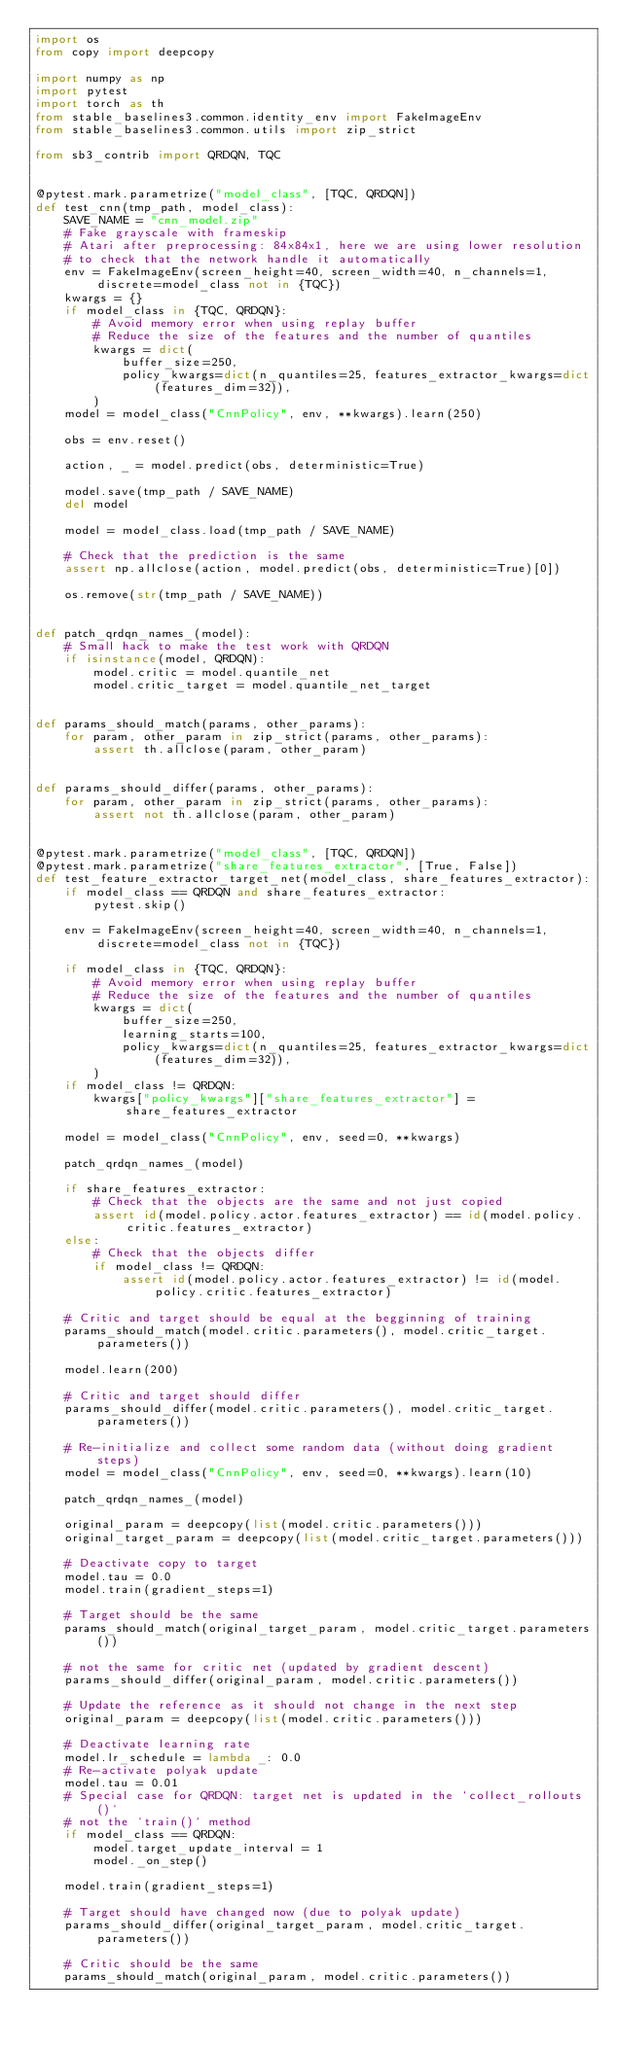<code> <loc_0><loc_0><loc_500><loc_500><_Python_>import os
from copy import deepcopy

import numpy as np
import pytest
import torch as th
from stable_baselines3.common.identity_env import FakeImageEnv
from stable_baselines3.common.utils import zip_strict

from sb3_contrib import QRDQN, TQC


@pytest.mark.parametrize("model_class", [TQC, QRDQN])
def test_cnn(tmp_path, model_class):
    SAVE_NAME = "cnn_model.zip"
    # Fake grayscale with frameskip
    # Atari after preprocessing: 84x84x1, here we are using lower resolution
    # to check that the network handle it automatically
    env = FakeImageEnv(screen_height=40, screen_width=40, n_channels=1, discrete=model_class not in {TQC})
    kwargs = {}
    if model_class in {TQC, QRDQN}:
        # Avoid memory error when using replay buffer
        # Reduce the size of the features and the number of quantiles
        kwargs = dict(
            buffer_size=250,
            policy_kwargs=dict(n_quantiles=25, features_extractor_kwargs=dict(features_dim=32)),
        )
    model = model_class("CnnPolicy", env, **kwargs).learn(250)

    obs = env.reset()

    action, _ = model.predict(obs, deterministic=True)

    model.save(tmp_path / SAVE_NAME)
    del model

    model = model_class.load(tmp_path / SAVE_NAME)

    # Check that the prediction is the same
    assert np.allclose(action, model.predict(obs, deterministic=True)[0])

    os.remove(str(tmp_path / SAVE_NAME))


def patch_qrdqn_names_(model):
    # Small hack to make the test work with QRDQN
    if isinstance(model, QRDQN):
        model.critic = model.quantile_net
        model.critic_target = model.quantile_net_target


def params_should_match(params, other_params):
    for param, other_param in zip_strict(params, other_params):
        assert th.allclose(param, other_param)


def params_should_differ(params, other_params):
    for param, other_param in zip_strict(params, other_params):
        assert not th.allclose(param, other_param)


@pytest.mark.parametrize("model_class", [TQC, QRDQN])
@pytest.mark.parametrize("share_features_extractor", [True, False])
def test_feature_extractor_target_net(model_class, share_features_extractor):
    if model_class == QRDQN and share_features_extractor:
        pytest.skip()

    env = FakeImageEnv(screen_height=40, screen_width=40, n_channels=1, discrete=model_class not in {TQC})

    if model_class in {TQC, QRDQN}:
        # Avoid memory error when using replay buffer
        # Reduce the size of the features and the number of quantiles
        kwargs = dict(
            buffer_size=250,
            learning_starts=100,
            policy_kwargs=dict(n_quantiles=25, features_extractor_kwargs=dict(features_dim=32)),
        )
    if model_class != QRDQN:
        kwargs["policy_kwargs"]["share_features_extractor"] = share_features_extractor

    model = model_class("CnnPolicy", env, seed=0, **kwargs)

    patch_qrdqn_names_(model)

    if share_features_extractor:
        # Check that the objects are the same and not just copied
        assert id(model.policy.actor.features_extractor) == id(model.policy.critic.features_extractor)
    else:
        # Check that the objects differ
        if model_class != QRDQN:
            assert id(model.policy.actor.features_extractor) != id(model.policy.critic.features_extractor)

    # Critic and target should be equal at the begginning of training
    params_should_match(model.critic.parameters(), model.critic_target.parameters())

    model.learn(200)

    # Critic and target should differ
    params_should_differ(model.critic.parameters(), model.critic_target.parameters())

    # Re-initialize and collect some random data (without doing gradient steps)
    model = model_class("CnnPolicy", env, seed=0, **kwargs).learn(10)

    patch_qrdqn_names_(model)

    original_param = deepcopy(list(model.critic.parameters()))
    original_target_param = deepcopy(list(model.critic_target.parameters()))

    # Deactivate copy to target
    model.tau = 0.0
    model.train(gradient_steps=1)

    # Target should be the same
    params_should_match(original_target_param, model.critic_target.parameters())

    # not the same for critic net (updated by gradient descent)
    params_should_differ(original_param, model.critic.parameters())

    # Update the reference as it should not change in the next step
    original_param = deepcopy(list(model.critic.parameters()))

    # Deactivate learning rate
    model.lr_schedule = lambda _: 0.0
    # Re-activate polyak update
    model.tau = 0.01
    # Special case for QRDQN: target net is updated in the `collect_rollouts()`
    # not the `train()` method
    if model_class == QRDQN:
        model.target_update_interval = 1
        model._on_step()

    model.train(gradient_steps=1)

    # Target should have changed now (due to polyak update)
    params_should_differ(original_target_param, model.critic_target.parameters())

    # Critic should be the same
    params_should_match(original_param, model.critic.parameters())
</code> 